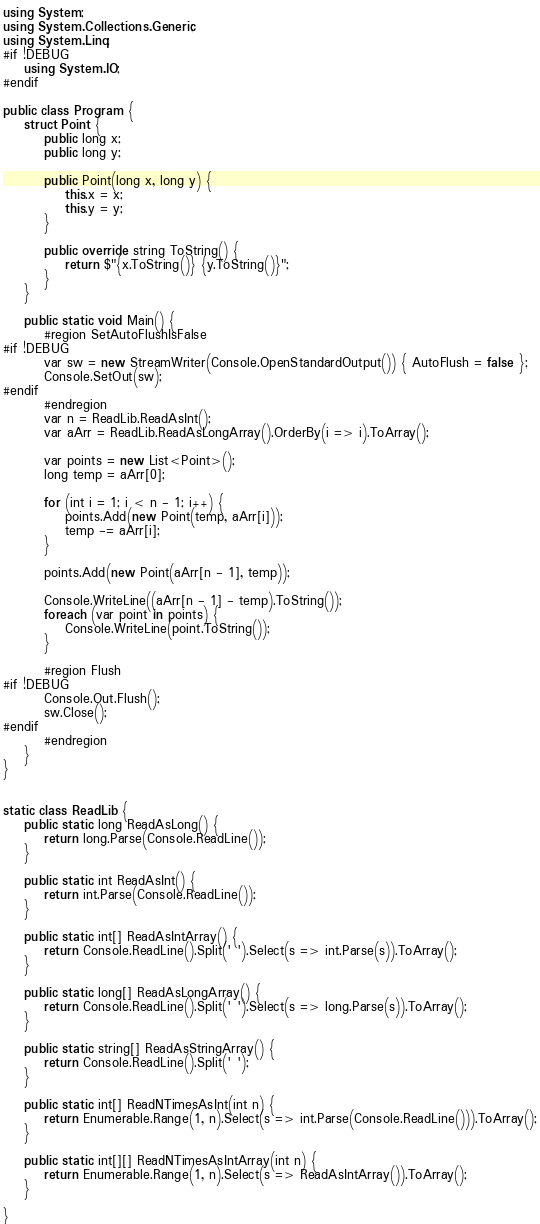Convert code to text. <code><loc_0><loc_0><loc_500><loc_500><_C#_>using System;
using System.Collections.Generic;
using System.Linq;
#if !DEBUG
    using System.IO;
#endif

public class Program {
    struct Point {
        public long x;
        public long y;

        public Point(long x, long y) {
            this.x = x;
            this.y = y;
        }

        public override string ToString() {
            return $"{x.ToString()} {y.ToString()}";
        }
    }

    public static void Main() {
        #region SetAutoFlushIsFalse
#if !DEBUG
        var sw = new StreamWriter(Console.OpenStandardOutput()) { AutoFlush = false };
        Console.SetOut(sw);
#endif
        #endregion
        var n = ReadLib.ReadAsInt();
        var aArr = ReadLib.ReadAsLongArray().OrderBy(i => i).ToArray();

        var points = new List<Point>();
        long temp = aArr[0];

        for (int i = 1; i < n - 1; i++) {
            points.Add(new Point(temp, aArr[i]));
            temp -= aArr[i];
        }

        points.Add(new Point(aArr[n - 1], temp));

        Console.WriteLine((aArr[n - 1] - temp).ToString());
        foreach (var point in points) {
            Console.WriteLine(point.ToString());
        }

        #region Flush
#if !DEBUG
        Console.Out.Flush();
        sw.Close();
#endif
        #endregion
    }
}


static class ReadLib {
    public static long ReadAsLong() {
        return long.Parse(Console.ReadLine());
    }

    public static int ReadAsInt() {
        return int.Parse(Console.ReadLine());
    }

    public static int[] ReadAsIntArray() {
        return Console.ReadLine().Split(' ').Select(s => int.Parse(s)).ToArray();
    }

    public static long[] ReadAsLongArray() {
        return Console.ReadLine().Split(' ').Select(s => long.Parse(s)).ToArray();
    }

    public static string[] ReadAsStringArray() {
        return Console.ReadLine().Split(' ');
    }

    public static int[] ReadNTimesAsInt(int n) {
        return Enumerable.Range(1, n).Select(s => int.Parse(Console.ReadLine())).ToArray();
    }

    public static int[][] ReadNTimesAsIntArray(int n) {
        return Enumerable.Range(1, n).Select(s => ReadAsIntArray()).ToArray();
    }

}</code> 